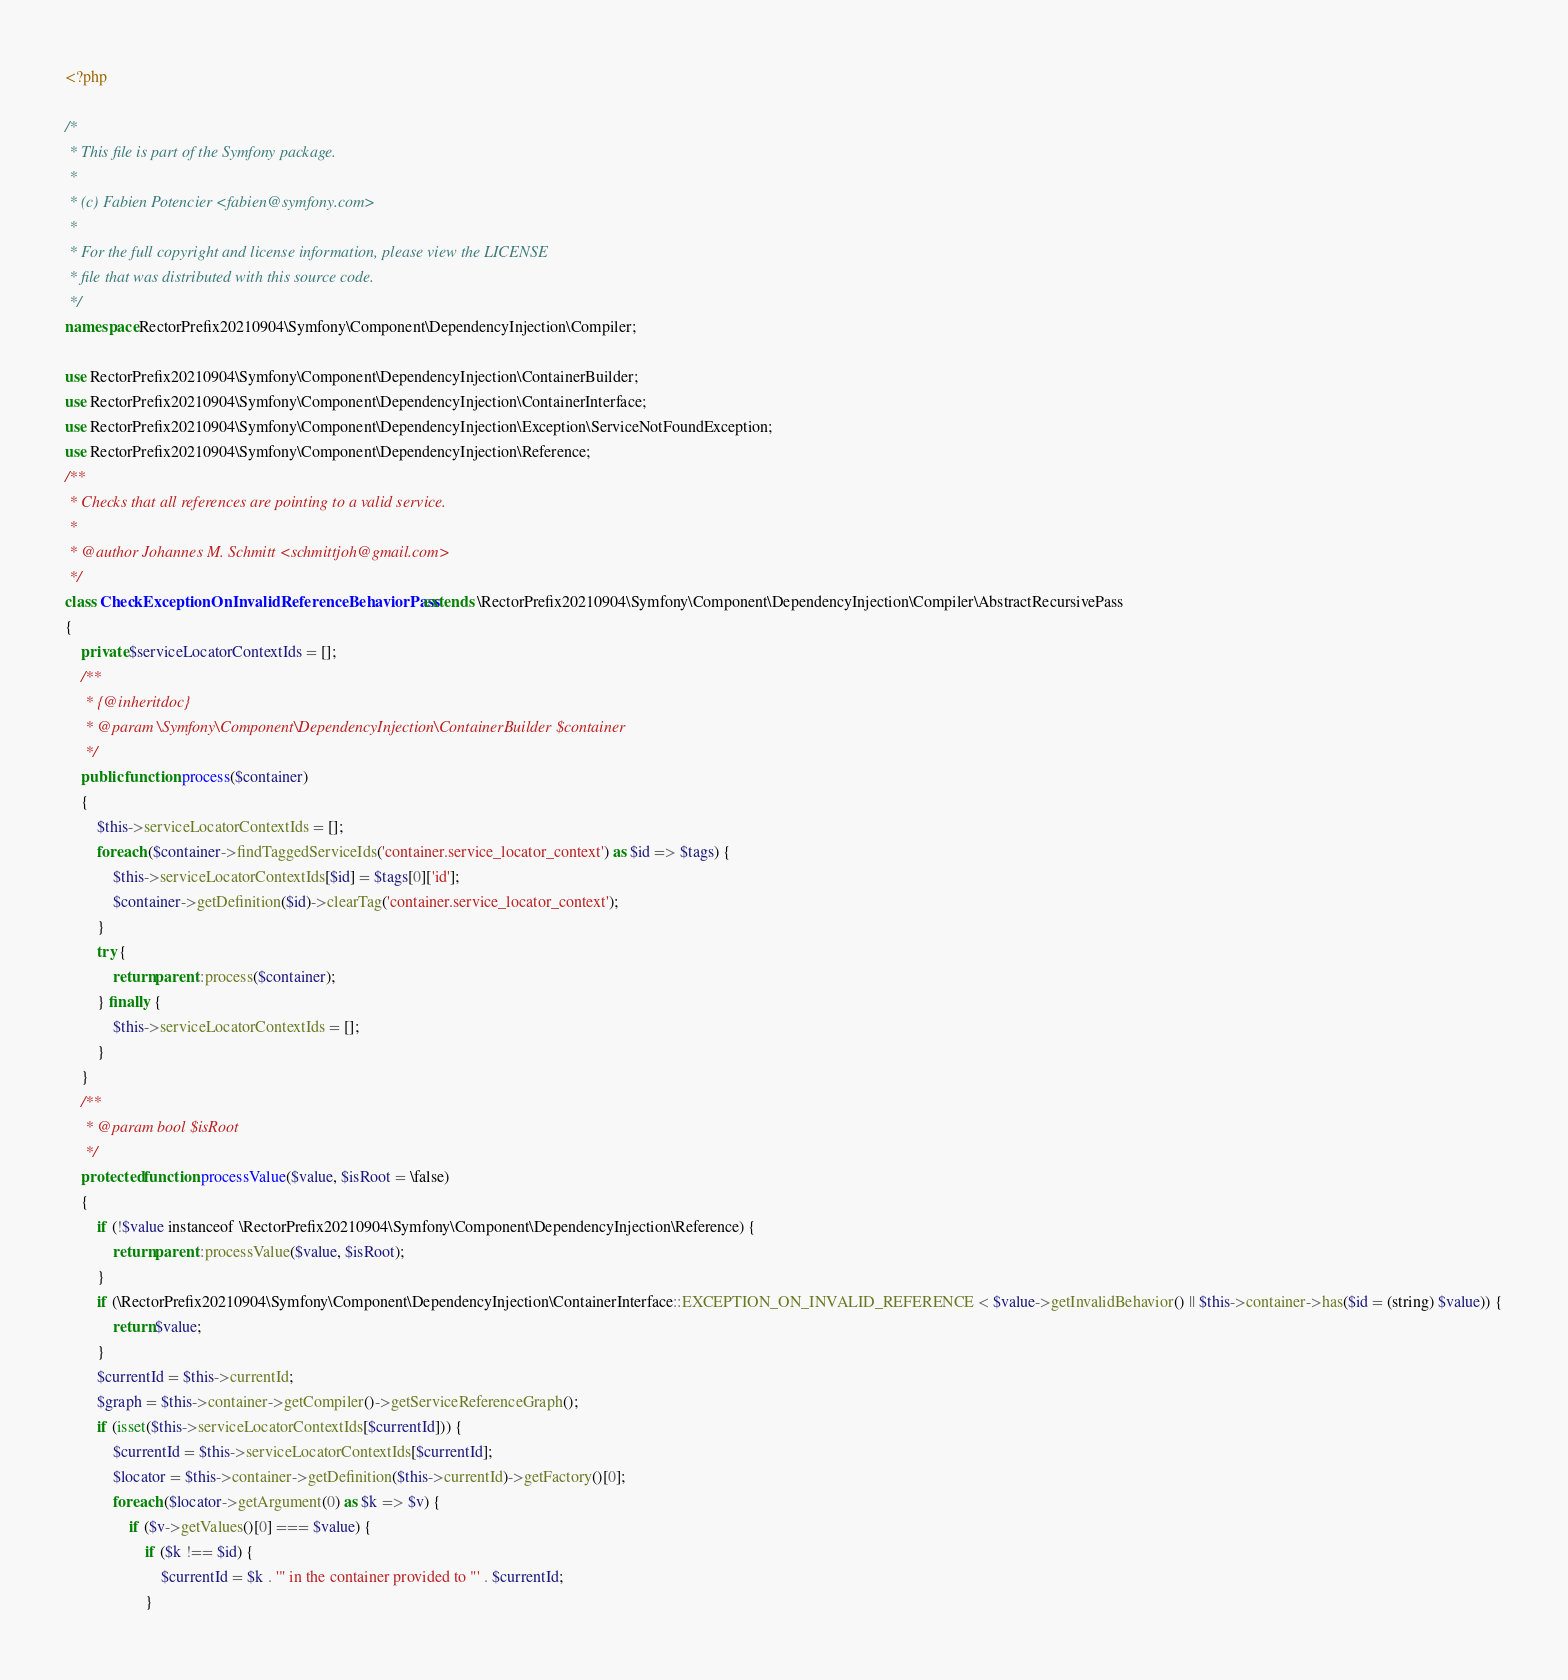<code> <loc_0><loc_0><loc_500><loc_500><_PHP_><?php

/*
 * This file is part of the Symfony package.
 *
 * (c) Fabien Potencier <fabien@symfony.com>
 *
 * For the full copyright and license information, please view the LICENSE
 * file that was distributed with this source code.
 */
namespace RectorPrefix20210904\Symfony\Component\DependencyInjection\Compiler;

use RectorPrefix20210904\Symfony\Component\DependencyInjection\ContainerBuilder;
use RectorPrefix20210904\Symfony\Component\DependencyInjection\ContainerInterface;
use RectorPrefix20210904\Symfony\Component\DependencyInjection\Exception\ServiceNotFoundException;
use RectorPrefix20210904\Symfony\Component\DependencyInjection\Reference;
/**
 * Checks that all references are pointing to a valid service.
 *
 * @author Johannes M. Schmitt <schmittjoh@gmail.com>
 */
class CheckExceptionOnInvalidReferenceBehaviorPass extends \RectorPrefix20210904\Symfony\Component\DependencyInjection\Compiler\AbstractRecursivePass
{
    private $serviceLocatorContextIds = [];
    /**
     * {@inheritdoc}
     * @param \Symfony\Component\DependencyInjection\ContainerBuilder $container
     */
    public function process($container)
    {
        $this->serviceLocatorContextIds = [];
        foreach ($container->findTaggedServiceIds('container.service_locator_context') as $id => $tags) {
            $this->serviceLocatorContextIds[$id] = $tags[0]['id'];
            $container->getDefinition($id)->clearTag('container.service_locator_context');
        }
        try {
            return parent::process($container);
        } finally {
            $this->serviceLocatorContextIds = [];
        }
    }
    /**
     * @param bool $isRoot
     */
    protected function processValue($value, $isRoot = \false)
    {
        if (!$value instanceof \RectorPrefix20210904\Symfony\Component\DependencyInjection\Reference) {
            return parent::processValue($value, $isRoot);
        }
        if (\RectorPrefix20210904\Symfony\Component\DependencyInjection\ContainerInterface::EXCEPTION_ON_INVALID_REFERENCE < $value->getInvalidBehavior() || $this->container->has($id = (string) $value)) {
            return $value;
        }
        $currentId = $this->currentId;
        $graph = $this->container->getCompiler()->getServiceReferenceGraph();
        if (isset($this->serviceLocatorContextIds[$currentId])) {
            $currentId = $this->serviceLocatorContextIds[$currentId];
            $locator = $this->container->getDefinition($this->currentId)->getFactory()[0];
            foreach ($locator->getArgument(0) as $k => $v) {
                if ($v->getValues()[0] === $value) {
                    if ($k !== $id) {
                        $currentId = $k . '" in the container provided to "' . $currentId;
                    }</code> 